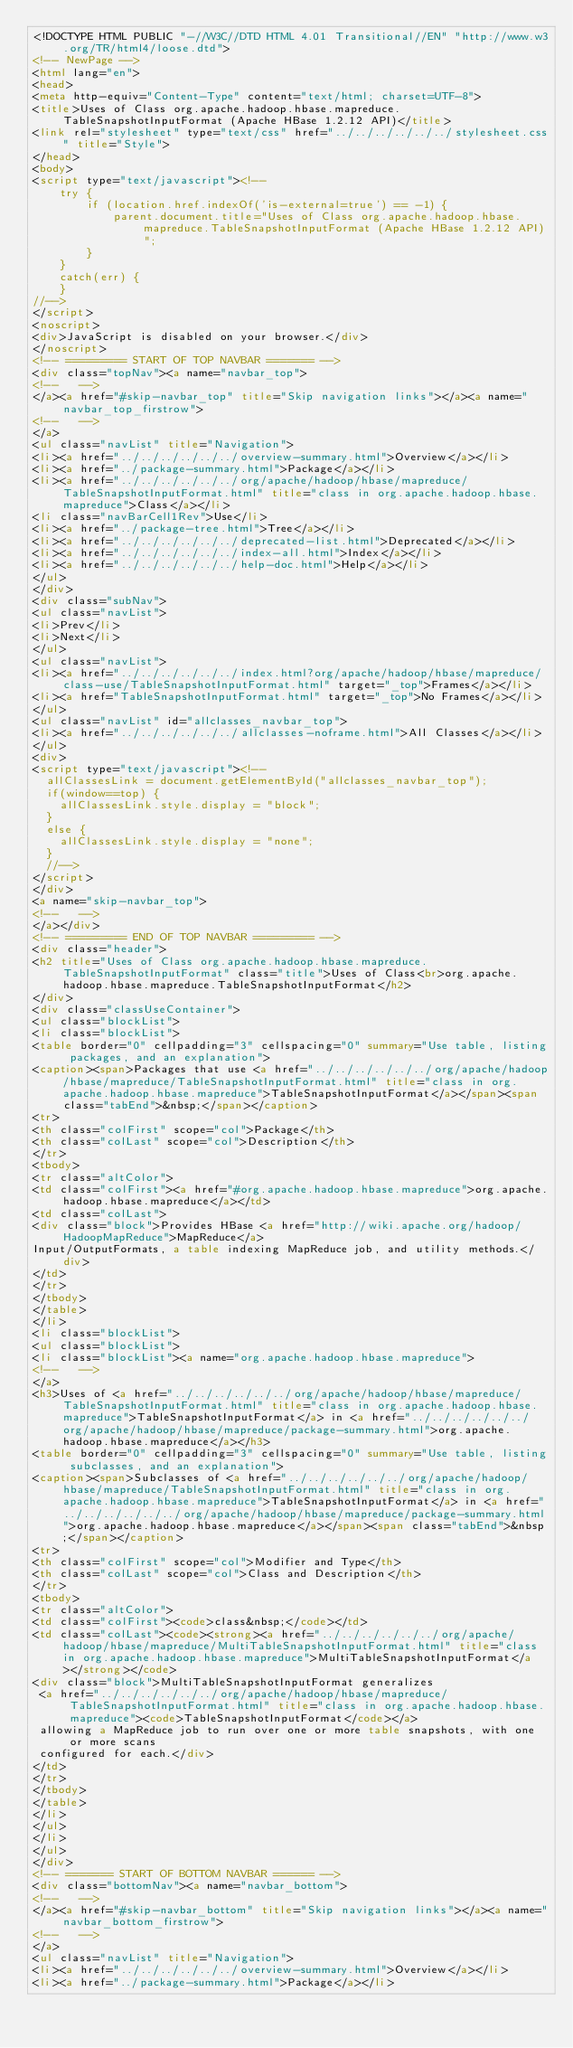Convert code to text. <code><loc_0><loc_0><loc_500><loc_500><_HTML_><!DOCTYPE HTML PUBLIC "-//W3C//DTD HTML 4.01 Transitional//EN" "http://www.w3.org/TR/html4/loose.dtd">
<!-- NewPage -->
<html lang="en">
<head>
<meta http-equiv="Content-Type" content="text/html; charset=UTF-8">
<title>Uses of Class org.apache.hadoop.hbase.mapreduce.TableSnapshotInputFormat (Apache HBase 1.2.12 API)</title>
<link rel="stylesheet" type="text/css" href="../../../../../../stylesheet.css" title="Style">
</head>
<body>
<script type="text/javascript"><!--
    try {
        if (location.href.indexOf('is-external=true') == -1) {
            parent.document.title="Uses of Class org.apache.hadoop.hbase.mapreduce.TableSnapshotInputFormat (Apache HBase 1.2.12 API)";
        }
    }
    catch(err) {
    }
//-->
</script>
<noscript>
<div>JavaScript is disabled on your browser.</div>
</noscript>
<!-- ========= START OF TOP NAVBAR ======= -->
<div class="topNav"><a name="navbar_top">
<!--   -->
</a><a href="#skip-navbar_top" title="Skip navigation links"></a><a name="navbar_top_firstrow">
<!--   -->
</a>
<ul class="navList" title="Navigation">
<li><a href="../../../../../../overview-summary.html">Overview</a></li>
<li><a href="../package-summary.html">Package</a></li>
<li><a href="../../../../../../org/apache/hadoop/hbase/mapreduce/TableSnapshotInputFormat.html" title="class in org.apache.hadoop.hbase.mapreduce">Class</a></li>
<li class="navBarCell1Rev">Use</li>
<li><a href="../package-tree.html">Tree</a></li>
<li><a href="../../../../../../deprecated-list.html">Deprecated</a></li>
<li><a href="../../../../../../index-all.html">Index</a></li>
<li><a href="../../../../../../help-doc.html">Help</a></li>
</ul>
</div>
<div class="subNav">
<ul class="navList">
<li>Prev</li>
<li>Next</li>
</ul>
<ul class="navList">
<li><a href="../../../../../../index.html?org/apache/hadoop/hbase/mapreduce/class-use/TableSnapshotInputFormat.html" target="_top">Frames</a></li>
<li><a href="TableSnapshotInputFormat.html" target="_top">No Frames</a></li>
</ul>
<ul class="navList" id="allclasses_navbar_top">
<li><a href="../../../../../../allclasses-noframe.html">All Classes</a></li>
</ul>
<div>
<script type="text/javascript"><!--
  allClassesLink = document.getElementById("allclasses_navbar_top");
  if(window==top) {
    allClassesLink.style.display = "block";
  }
  else {
    allClassesLink.style.display = "none";
  }
  //-->
</script>
</div>
<a name="skip-navbar_top">
<!--   -->
</a></div>
<!-- ========= END OF TOP NAVBAR ========= -->
<div class="header">
<h2 title="Uses of Class org.apache.hadoop.hbase.mapreduce.TableSnapshotInputFormat" class="title">Uses of Class<br>org.apache.hadoop.hbase.mapreduce.TableSnapshotInputFormat</h2>
</div>
<div class="classUseContainer">
<ul class="blockList">
<li class="blockList">
<table border="0" cellpadding="3" cellspacing="0" summary="Use table, listing packages, and an explanation">
<caption><span>Packages that use <a href="../../../../../../org/apache/hadoop/hbase/mapreduce/TableSnapshotInputFormat.html" title="class in org.apache.hadoop.hbase.mapreduce">TableSnapshotInputFormat</a></span><span class="tabEnd">&nbsp;</span></caption>
<tr>
<th class="colFirst" scope="col">Package</th>
<th class="colLast" scope="col">Description</th>
</tr>
<tbody>
<tr class="altColor">
<td class="colFirst"><a href="#org.apache.hadoop.hbase.mapreduce">org.apache.hadoop.hbase.mapreduce</a></td>
<td class="colLast">
<div class="block">Provides HBase <a href="http://wiki.apache.org/hadoop/HadoopMapReduce">MapReduce</a>
Input/OutputFormats, a table indexing MapReduce job, and utility methods.</div>
</td>
</tr>
</tbody>
</table>
</li>
<li class="blockList">
<ul class="blockList">
<li class="blockList"><a name="org.apache.hadoop.hbase.mapreduce">
<!--   -->
</a>
<h3>Uses of <a href="../../../../../../org/apache/hadoop/hbase/mapreduce/TableSnapshotInputFormat.html" title="class in org.apache.hadoop.hbase.mapreduce">TableSnapshotInputFormat</a> in <a href="../../../../../../org/apache/hadoop/hbase/mapreduce/package-summary.html">org.apache.hadoop.hbase.mapreduce</a></h3>
<table border="0" cellpadding="3" cellspacing="0" summary="Use table, listing subclasses, and an explanation">
<caption><span>Subclasses of <a href="../../../../../../org/apache/hadoop/hbase/mapreduce/TableSnapshotInputFormat.html" title="class in org.apache.hadoop.hbase.mapreduce">TableSnapshotInputFormat</a> in <a href="../../../../../../org/apache/hadoop/hbase/mapreduce/package-summary.html">org.apache.hadoop.hbase.mapreduce</a></span><span class="tabEnd">&nbsp;</span></caption>
<tr>
<th class="colFirst" scope="col">Modifier and Type</th>
<th class="colLast" scope="col">Class and Description</th>
</tr>
<tbody>
<tr class="altColor">
<td class="colFirst"><code>class&nbsp;</code></td>
<td class="colLast"><code><strong><a href="../../../../../../org/apache/hadoop/hbase/mapreduce/MultiTableSnapshotInputFormat.html" title="class in org.apache.hadoop.hbase.mapreduce">MultiTableSnapshotInputFormat</a></strong></code>
<div class="block">MultiTableSnapshotInputFormat generalizes
 <a href="../../../../../../org/apache/hadoop/hbase/mapreduce/TableSnapshotInputFormat.html" title="class in org.apache.hadoop.hbase.mapreduce"><code>TableSnapshotInputFormat</code></a>
 allowing a MapReduce job to run over one or more table snapshots, with one or more scans
 configured for each.</div>
</td>
</tr>
</tbody>
</table>
</li>
</ul>
</li>
</ul>
</div>
<!-- ======= START OF BOTTOM NAVBAR ====== -->
<div class="bottomNav"><a name="navbar_bottom">
<!--   -->
</a><a href="#skip-navbar_bottom" title="Skip navigation links"></a><a name="navbar_bottom_firstrow">
<!--   -->
</a>
<ul class="navList" title="Navigation">
<li><a href="../../../../../../overview-summary.html">Overview</a></li>
<li><a href="../package-summary.html">Package</a></li></code> 